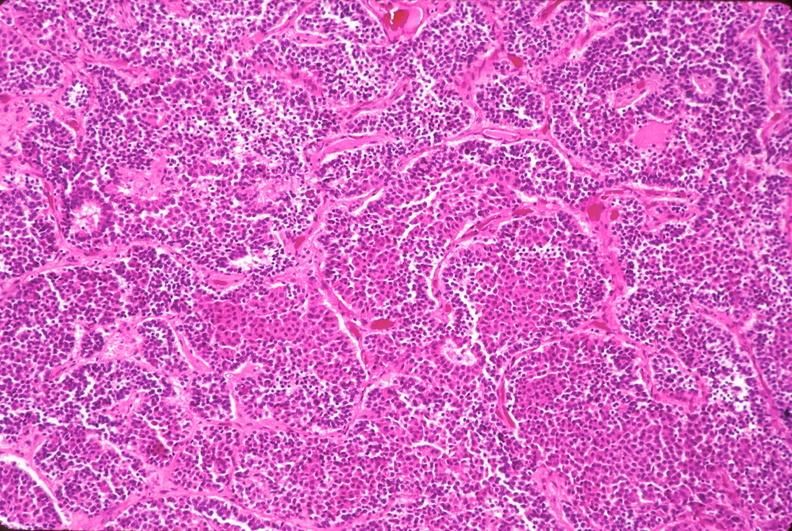s endocrine present?
Answer the question using a single word or phrase. Yes 